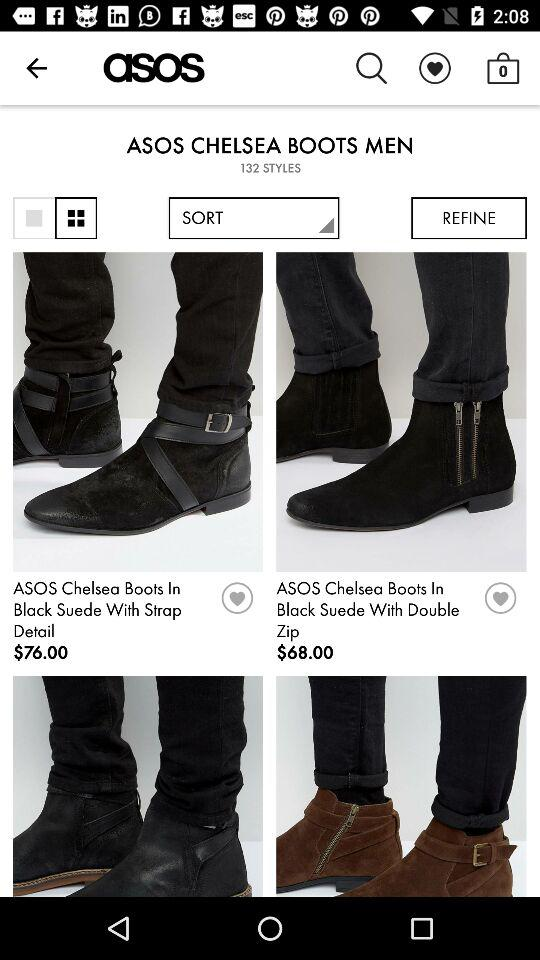How many items are in the bag? There are 0 items in the bag. 